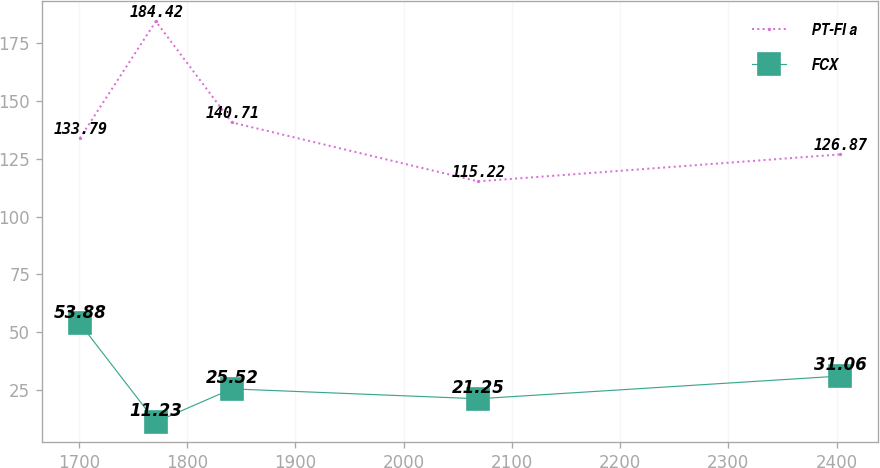Convert chart. <chart><loc_0><loc_0><loc_500><loc_500><line_chart><ecel><fcel>PT-FI a<fcel>FCX<nl><fcel>1700.99<fcel>133.79<fcel>53.88<nl><fcel>1771.19<fcel>184.42<fcel>11.23<nl><fcel>1841.39<fcel>140.71<fcel>25.52<nl><fcel>2068.84<fcel>115.22<fcel>21.25<nl><fcel>2403.02<fcel>126.87<fcel>31.06<nl></chart> 